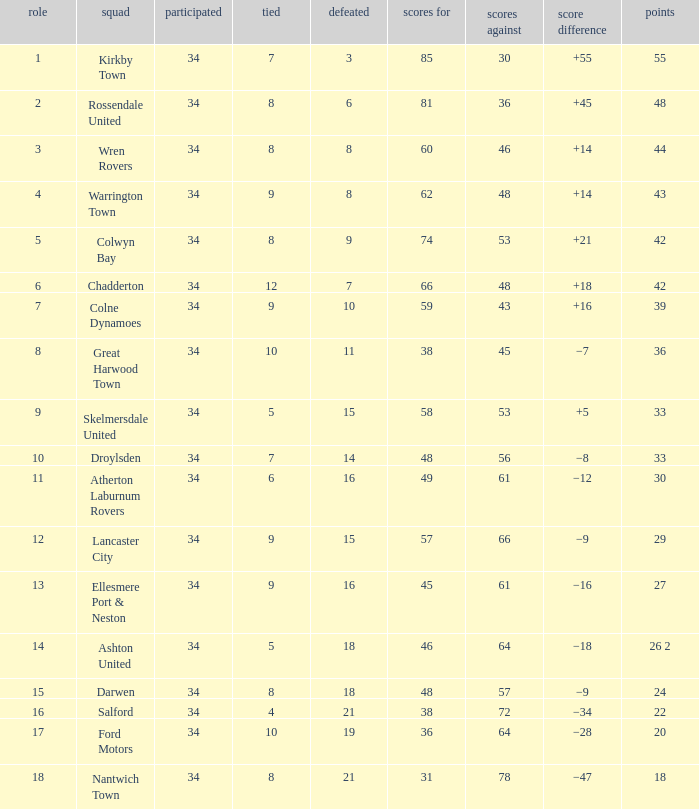What is the cumulative sum of positions when surpassing 48 goals against, 1 among 29 points are played, and less than 34 games have occurred? 0.0. 